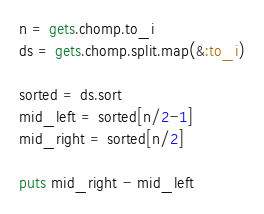<code> <loc_0><loc_0><loc_500><loc_500><_Ruby_>n = gets.chomp.to_i
ds = gets.chomp.split.map(&:to_i)

sorted = ds.sort
mid_left = sorted[n/2-1]
mid_right = sorted[n/2]

puts mid_right - mid_left
</code> 